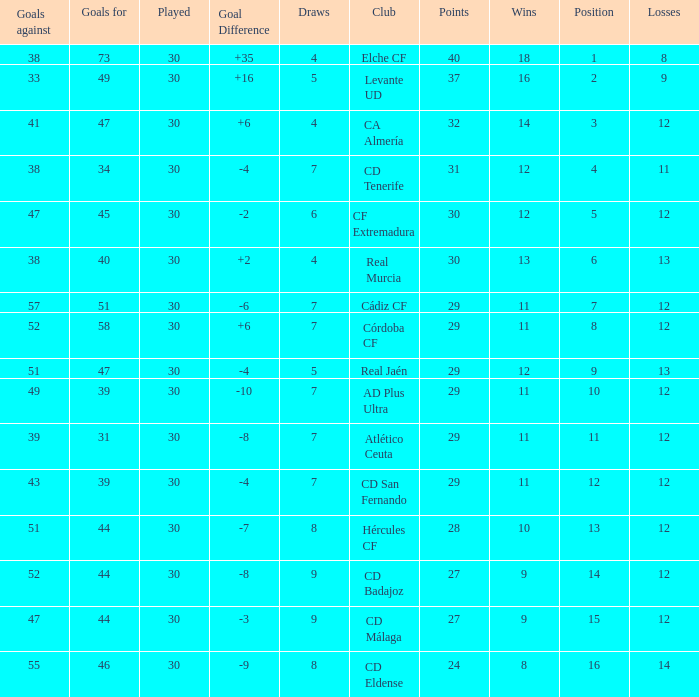What is the lowest amount of draws with less than 12 wins and less than 30 played? None. 